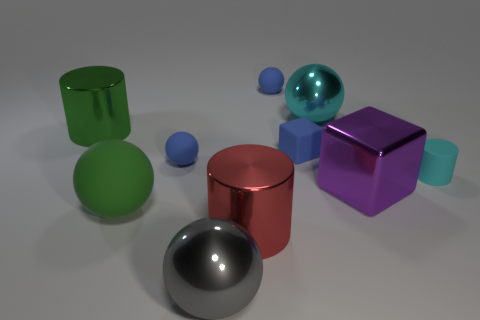Is there anything else that is the same color as the tiny matte block?
Provide a short and direct response. Yes. There is a small sphere behind the big cyan shiny ball; is it the same color as the metal sphere that is in front of the tiny cube?
Offer a very short reply. No. Is the number of big purple things that are behind the gray thing greater than the number of tiny blue rubber things on the left side of the big red thing?
Provide a succinct answer. No. What is the big green sphere made of?
Give a very brief answer. Rubber. What shape is the big object that is in front of the shiny cylinder in front of the cylinder behind the rubber cube?
Offer a very short reply. Sphere. How many other objects are the same material as the large green cylinder?
Ensure brevity in your answer.  4. Is the material of the big sphere behind the big green cylinder the same as the tiny sphere that is behind the cyan metallic ball?
Your answer should be compact. No. What number of blue things are in front of the cyan shiny object and left of the tiny cube?
Provide a short and direct response. 1. Are there any large cyan objects of the same shape as the red shiny thing?
Provide a short and direct response. No. What is the shape of the green object that is the same size as the green cylinder?
Your answer should be very brief. Sphere. 